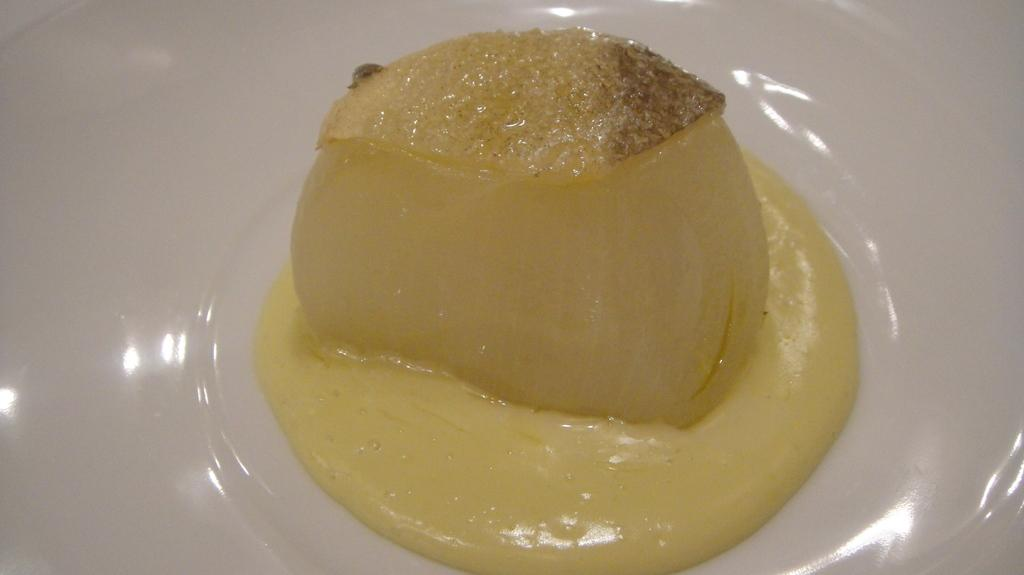What is the main subject of the image? There is a food item in the image. How is the food item presented in the image? The food item is on a white plate. What color is the food item? The food item is yellow in color. How many trucks are carrying the food item in the image? There are no trucks present in the image, as it only features a food item on a white plate. 